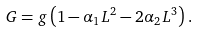Convert formula to latex. <formula><loc_0><loc_0><loc_500><loc_500>G = g \left ( 1 - \alpha _ { 1 } L ^ { 2 } - 2 \alpha _ { 2 } L ^ { 3 } \right ) .</formula> 